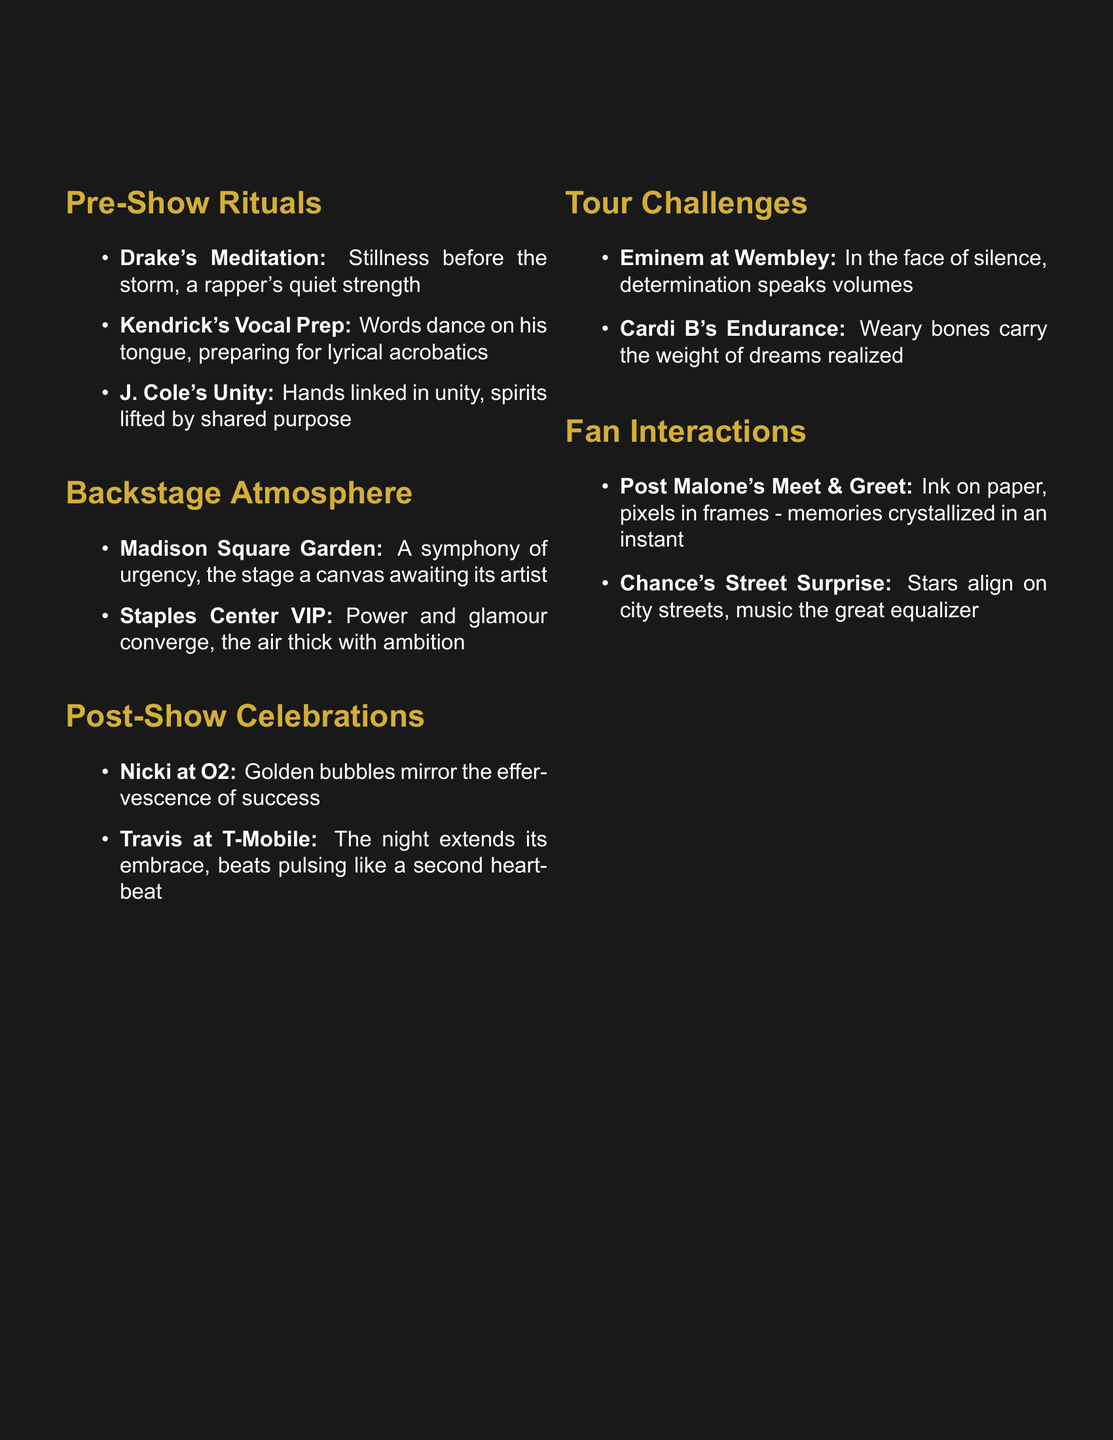What is Drake's pre-show ritual? Drake's pre-show ritual is meditation, which he performs for 30 minutes to center himself before each show.
Answer: Meditation What does Kendrick Lamar do to prepare his voice? Kendrick Lamar performs an intricate series of tongue twisters and breathing exercises as vocal warm-ups.
Answer: Vocal warm-ups Which venue had nervous energy among stagehands? Nervous energy was observed at Madison Square Garden, where stagehands rushed to make last-minute adjustments.
Answer: Madison Square Garden What event did Nicki Minaj celebrate after her show? Nicki Minaj celebrated with a champagne toast after a sold-out show at the O2 Arena.
Answer: Champagne toast What challenge did Eminem face before going on stage? Eminem's team faced technical difficulties with a malfunctioning microphone moments before his performance.
Answer: Technical difficulties What activity did Post Malone engage in with fans? Post Malone spent an hour doing meet and greets, signing autographs and taking photos with fans.
Answer: Meet and greet What sentiment does J. Cole express during his pre-show ritual? J. Cole expresses gratitude and unity by gathering his entire crew for a moment of prayer.
Answer: Prayer circle What type of atmosphere is described in the VIP area at Staples Center? The VIP area at the Staples Center is described as one where power and glamour converge.
Answer: Power and glamour In what way do the post-show celebrations reflect success? The golden bubbles of champagne during celebrations mirror the effervescence of success.
Answer: Golden bubbles 